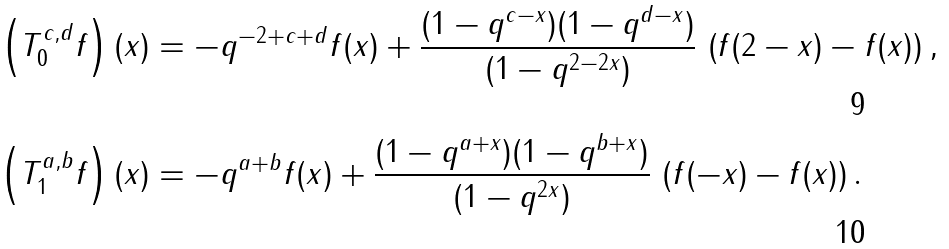<formula> <loc_0><loc_0><loc_500><loc_500>\left ( T _ { 0 } ^ { c , d } f \right ) ( x ) & = - q ^ { - 2 + c + d } f ( x ) + \frac { ( 1 - q ^ { c - x } ) ( 1 - q ^ { d - x } ) } { ( 1 - q ^ { 2 - 2 x } ) } \, \left ( f ( 2 - x ) - f ( x ) \right ) , \\ \left ( T _ { 1 } ^ { a , b } f \right ) ( x ) & = - q ^ { a + b } f ( x ) + \frac { ( 1 - q ^ { a + x } ) ( 1 - q ^ { b + x } ) } { ( 1 - q ^ { 2 x } ) } \, \left ( f ( - x ) - f ( x ) \right ) .</formula> 